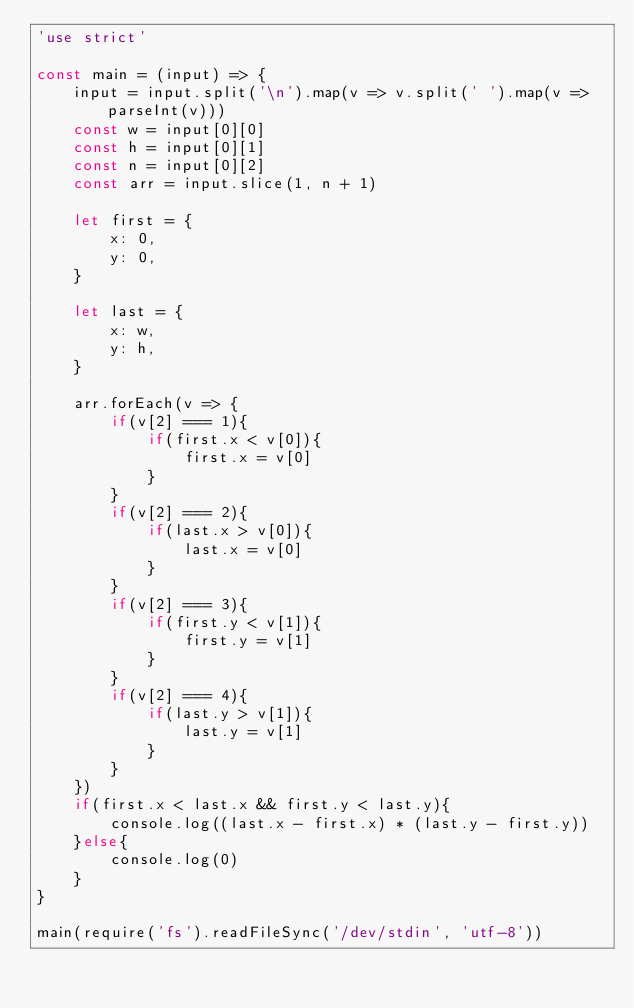Convert code to text. <code><loc_0><loc_0><loc_500><loc_500><_JavaScript_>'use strict'

const main = (input) => {
    input = input.split('\n').map(v => v.split(' ').map(v => parseInt(v)))
    const w = input[0][0]
    const h = input[0][1]
    const n = input[0][2]
    const arr = input.slice(1, n + 1)

    let first = {
        x: 0,
        y: 0,
    }

    let last = {
        x: w,
        y: h,
    }

    arr.forEach(v => {
        if(v[2] === 1){
            if(first.x < v[0]){
                first.x = v[0]
            }
        }
        if(v[2] === 2){
            if(last.x > v[0]){
                last.x = v[0]
            }
        }
        if(v[2] === 3){
            if(first.y < v[1]){
                first.y = v[1]
            }
        }
        if(v[2] === 4){
            if(last.y > v[1]){
                last.y = v[1]
            }
        }
    })
    if(first.x < last.x && first.y < last.y){
        console.log((last.x - first.x) * (last.y - first.y))
    }else{
        console.log(0)
    }
}

main(require('fs').readFileSync('/dev/stdin', 'utf-8'))
</code> 